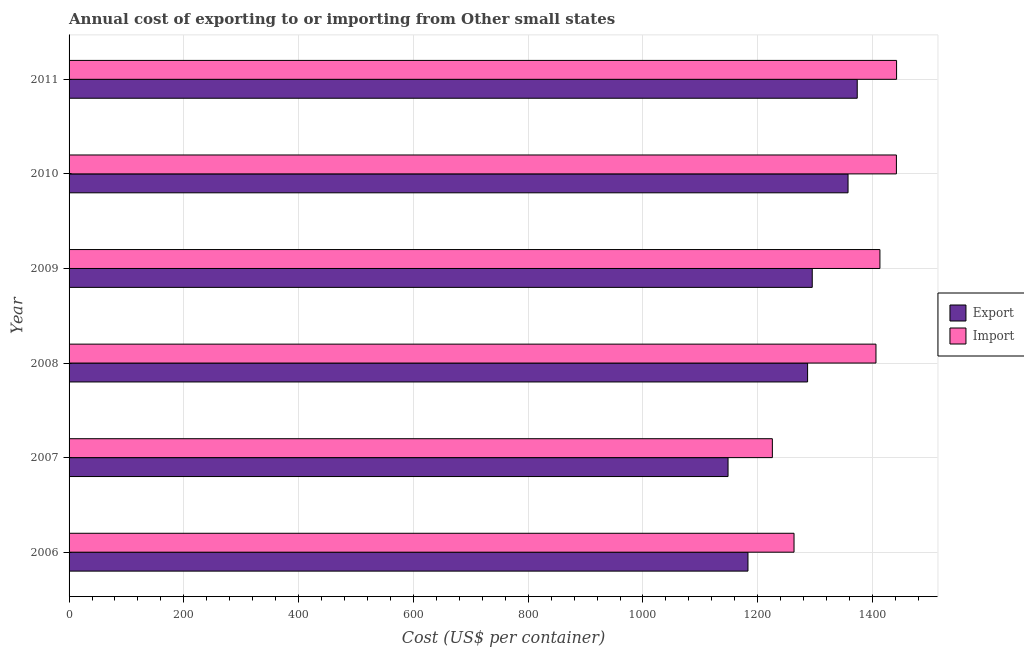How many different coloured bars are there?
Give a very brief answer. 2. Are the number of bars per tick equal to the number of legend labels?
Keep it short and to the point. Yes. How many bars are there on the 4th tick from the top?
Your answer should be very brief. 2. How many bars are there on the 1st tick from the bottom?
Provide a succinct answer. 2. What is the label of the 1st group of bars from the top?
Your answer should be very brief. 2011. In how many cases, is the number of bars for a given year not equal to the number of legend labels?
Provide a succinct answer. 0. What is the export cost in 2011?
Keep it short and to the point. 1373.39. Across all years, what is the maximum import cost?
Your response must be concise. 1441.94. Across all years, what is the minimum export cost?
Ensure brevity in your answer.  1148.28. In which year was the import cost maximum?
Ensure brevity in your answer.  2011. What is the total export cost in the graph?
Your answer should be very brief. 7643.94. What is the difference between the export cost in 2007 and that in 2008?
Keep it short and to the point. -138.61. What is the difference between the import cost in 2008 and the export cost in 2010?
Provide a short and direct response. 48.67. What is the average export cost per year?
Keep it short and to the point. 1273.99. In the year 2007, what is the difference between the import cost and export cost?
Provide a short and direct response. 77.22. In how many years, is the export cost greater than 1280 US$?
Offer a very short reply. 4. What is the ratio of the export cost in 2009 to that in 2011?
Your answer should be very brief. 0.94. Is the difference between the import cost in 2007 and 2010 greater than the difference between the export cost in 2007 and 2010?
Ensure brevity in your answer.  No. What is the difference between the highest and the lowest export cost?
Offer a very short reply. 225.11. What does the 2nd bar from the top in 2008 represents?
Keep it short and to the point. Export. What does the 1st bar from the bottom in 2010 represents?
Ensure brevity in your answer.  Export. Are all the bars in the graph horizontal?
Give a very brief answer. Yes. How many legend labels are there?
Ensure brevity in your answer.  2. What is the title of the graph?
Provide a succinct answer. Annual cost of exporting to or importing from Other small states. Does "Research and Development" appear as one of the legend labels in the graph?
Your response must be concise. No. What is the label or title of the X-axis?
Offer a terse response. Cost (US$ per container). What is the label or title of the Y-axis?
Provide a short and direct response. Year. What is the Cost (US$ per container) in Export in 2006?
Offer a very short reply. 1183. What is the Cost (US$ per container) in Import in 2006?
Ensure brevity in your answer.  1263.28. What is the Cost (US$ per container) of Export in 2007?
Keep it short and to the point. 1148.28. What is the Cost (US$ per container) in Import in 2007?
Offer a terse response. 1225.5. What is the Cost (US$ per container) in Export in 2008?
Your response must be concise. 1286.89. What is the Cost (US$ per container) of Import in 2008?
Keep it short and to the point. 1406.06. What is the Cost (US$ per container) in Export in 2009?
Ensure brevity in your answer.  1295. What is the Cost (US$ per container) in Import in 2009?
Provide a short and direct response. 1412.94. What is the Cost (US$ per container) in Export in 2010?
Your answer should be very brief. 1357.39. What is the Cost (US$ per container) of Import in 2010?
Your response must be concise. 1441.67. What is the Cost (US$ per container) of Export in 2011?
Make the answer very short. 1373.39. What is the Cost (US$ per container) in Import in 2011?
Ensure brevity in your answer.  1441.94. Across all years, what is the maximum Cost (US$ per container) of Export?
Give a very brief answer. 1373.39. Across all years, what is the maximum Cost (US$ per container) in Import?
Your response must be concise. 1441.94. Across all years, what is the minimum Cost (US$ per container) of Export?
Provide a succinct answer. 1148.28. Across all years, what is the minimum Cost (US$ per container) of Import?
Provide a succinct answer. 1225.5. What is the total Cost (US$ per container) in Export in the graph?
Give a very brief answer. 7643.94. What is the total Cost (US$ per container) of Import in the graph?
Ensure brevity in your answer.  8191.39. What is the difference between the Cost (US$ per container) of Export in 2006 and that in 2007?
Your answer should be very brief. 34.72. What is the difference between the Cost (US$ per container) of Import in 2006 and that in 2007?
Your answer should be compact. 37.78. What is the difference between the Cost (US$ per container) of Export in 2006 and that in 2008?
Give a very brief answer. -103.89. What is the difference between the Cost (US$ per container) in Import in 2006 and that in 2008?
Your response must be concise. -142.78. What is the difference between the Cost (US$ per container) of Export in 2006 and that in 2009?
Your response must be concise. -112. What is the difference between the Cost (US$ per container) of Import in 2006 and that in 2009?
Your answer should be compact. -149.67. What is the difference between the Cost (US$ per container) in Export in 2006 and that in 2010?
Give a very brief answer. -174.39. What is the difference between the Cost (US$ per container) of Import in 2006 and that in 2010?
Offer a very short reply. -178.39. What is the difference between the Cost (US$ per container) in Export in 2006 and that in 2011?
Provide a succinct answer. -190.39. What is the difference between the Cost (US$ per container) of Import in 2006 and that in 2011?
Make the answer very short. -178.67. What is the difference between the Cost (US$ per container) in Export in 2007 and that in 2008?
Your response must be concise. -138.61. What is the difference between the Cost (US$ per container) of Import in 2007 and that in 2008?
Give a very brief answer. -180.56. What is the difference between the Cost (US$ per container) of Export in 2007 and that in 2009?
Your response must be concise. -146.72. What is the difference between the Cost (US$ per container) in Import in 2007 and that in 2009?
Provide a short and direct response. -187.44. What is the difference between the Cost (US$ per container) in Export in 2007 and that in 2010?
Make the answer very short. -209.11. What is the difference between the Cost (US$ per container) in Import in 2007 and that in 2010?
Offer a terse response. -216.17. What is the difference between the Cost (US$ per container) of Export in 2007 and that in 2011?
Provide a succinct answer. -225.11. What is the difference between the Cost (US$ per container) of Import in 2007 and that in 2011?
Offer a very short reply. -216.44. What is the difference between the Cost (US$ per container) of Export in 2008 and that in 2009?
Your answer should be compact. -8.11. What is the difference between the Cost (US$ per container) of Import in 2008 and that in 2009?
Give a very brief answer. -6.89. What is the difference between the Cost (US$ per container) in Export in 2008 and that in 2010?
Provide a succinct answer. -70.5. What is the difference between the Cost (US$ per container) of Import in 2008 and that in 2010?
Give a very brief answer. -35.61. What is the difference between the Cost (US$ per container) of Export in 2008 and that in 2011?
Keep it short and to the point. -86.5. What is the difference between the Cost (US$ per container) of Import in 2008 and that in 2011?
Make the answer very short. -35.89. What is the difference between the Cost (US$ per container) of Export in 2009 and that in 2010?
Your answer should be very brief. -62.39. What is the difference between the Cost (US$ per container) in Import in 2009 and that in 2010?
Provide a succinct answer. -28.72. What is the difference between the Cost (US$ per container) in Export in 2009 and that in 2011?
Give a very brief answer. -78.39. What is the difference between the Cost (US$ per container) in Export in 2010 and that in 2011?
Offer a very short reply. -16. What is the difference between the Cost (US$ per container) of Import in 2010 and that in 2011?
Offer a terse response. -0.28. What is the difference between the Cost (US$ per container) in Export in 2006 and the Cost (US$ per container) in Import in 2007?
Your answer should be compact. -42.5. What is the difference between the Cost (US$ per container) in Export in 2006 and the Cost (US$ per container) in Import in 2008?
Your answer should be very brief. -223.06. What is the difference between the Cost (US$ per container) in Export in 2006 and the Cost (US$ per container) in Import in 2009?
Offer a terse response. -229.94. What is the difference between the Cost (US$ per container) of Export in 2006 and the Cost (US$ per container) of Import in 2010?
Ensure brevity in your answer.  -258.67. What is the difference between the Cost (US$ per container) of Export in 2006 and the Cost (US$ per container) of Import in 2011?
Give a very brief answer. -258.94. What is the difference between the Cost (US$ per container) of Export in 2007 and the Cost (US$ per container) of Import in 2008?
Offer a very short reply. -257.78. What is the difference between the Cost (US$ per container) in Export in 2007 and the Cost (US$ per container) in Import in 2009?
Your answer should be compact. -264.67. What is the difference between the Cost (US$ per container) of Export in 2007 and the Cost (US$ per container) of Import in 2010?
Provide a succinct answer. -293.39. What is the difference between the Cost (US$ per container) in Export in 2007 and the Cost (US$ per container) in Import in 2011?
Make the answer very short. -293.67. What is the difference between the Cost (US$ per container) of Export in 2008 and the Cost (US$ per container) of Import in 2009?
Your answer should be very brief. -126.06. What is the difference between the Cost (US$ per container) of Export in 2008 and the Cost (US$ per container) of Import in 2010?
Make the answer very short. -154.78. What is the difference between the Cost (US$ per container) in Export in 2008 and the Cost (US$ per container) in Import in 2011?
Offer a terse response. -155.06. What is the difference between the Cost (US$ per container) of Export in 2009 and the Cost (US$ per container) of Import in 2010?
Provide a succinct answer. -146.67. What is the difference between the Cost (US$ per container) of Export in 2009 and the Cost (US$ per container) of Import in 2011?
Your answer should be very brief. -146.94. What is the difference between the Cost (US$ per container) of Export in 2010 and the Cost (US$ per container) of Import in 2011?
Give a very brief answer. -84.56. What is the average Cost (US$ per container) in Export per year?
Keep it short and to the point. 1273.99. What is the average Cost (US$ per container) of Import per year?
Provide a short and direct response. 1365.23. In the year 2006, what is the difference between the Cost (US$ per container) of Export and Cost (US$ per container) of Import?
Your answer should be compact. -80.28. In the year 2007, what is the difference between the Cost (US$ per container) of Export and Cost (US$ per container) of Import?
Offer a terse response. -77.22. In the year 2008, what is the difference between the Cost (US$ per container) in Export and Cost (US$ per container) in Import?
Make the answer very short. -119.17. In the year 2009, what is the difference between the Cost (US$ per container) of Export and Cost (US$ per container) of Import?
Keep it short and to the point. -117.94. In the year 2010, what is the difference between the Cost (US$ per container) of Export and Cost (US$ per container) of Import?
Provide a succinct answer. -84.28. In the year 2011, what is the difference between the Cost (US$ per container) in Export and Cost (US$ per container) in Import?
Offer a terse response. -68.56. What is the ratio of the Cost (US$ per container) of Export in 2006 to that in 2007?
Offer a very short reply. 1.03. What is the ratio of the Cost (US$ per container) in Import in 2006 to that in 2007?
Your response must be concise. 1.03. What is the ratio of the Cost (US$ per container) in Export in 2006 to that in 2008?
Your response must be concise. 0.92. What is the ratio of the Cost (US$ per container) of Import in 2006 to that in 2008?
Your answer should be very brief. 0.9. What is the ratio of the Cost (US$ per container) in Export in 2006 to that in 2009?
Give a very brief answer. 0.91. What is the ratio of the Cost (US$ per container) of Import in 2006 to that in 2009?
Offer a very short reply. 0.89. What is the ratio of the Cost (US$ per container) of Export in 2006 to that in 2010?
Your response must be concise. 0.87. What is the ratio of the Cost (US$ per container) in Import in 2006 to that in 2010?
Provide a succinct answer. 0.88. What is the ratio of the Cost (US$ per container) in Export in 2006 to that in 2011?
Make the answer very short. 0.86. What is the ratio of the Cost (US$ per container) of Import in 2006 to that in 2011?
Make the answer very short. 0.88. What is the ratio of the Cost (US$ per container) of Export in 2007 to that in 2008?
Your answer should be compact. 0.89. What is the ratio of the Cost (US$ per container) of Import in 2007 to that in 2008?
Make the answer very short. 0.87. What is the ratio of the Cost (US$ per container) of Export in 2007 to that in 2009?
Give a very brief answer. 0.89. What is the ratio of the Cost (US$ per container) in Import in 2007 to that in 2009?
Keep it short and to the point. 0.87. What is the ratio of the Cost (US$ per container) in Export in 2007 to that in 2010?
Give a very brief answer. 0.85. What is the ratio of the Cost (US$ per container) in Import in 2007 to that in 2010?
Offer a very short reply. 0.85. What is the ratio of the Cost (US$ per container) in Export in 2007 to that in 2011?
Provide a succinct answer. 0.84. What is the ratio of the Cost (US$ per container) of Import in 2007 to that in 2011?
Keep it short and to the point. 0.85. What is the ratio of the Cost (US$ per container) in Import in 2008 to that in 2009?
Keep it short and to the point. 1. What is the ratio of the Cost (US$ per container) in Export in 2008 to that in 2010?
Ensure brevity in your answer.  0.95. What is the ratio of the Cost (US$ per container) in Import in 2008 to that in 2010?
Your answer should be compact. 0.98. What is the ratio of the Cost (US$ per container) in Export in 2008 to that in 2011?
Give a very brief answer. 0.94. What is the ratio of the Cost (US$ per container) in Import in 2008 to that in 2011?
Provide a succinct answer. 0.98. What is the ratio of the Cost (US$ per container) of Export in 2009 to that in 2010?
Your answer should be very brief. 0.95. What is the ratio of the Cost (US$ per container) of Import in 2009 to that in 2010?
Offer a very short reply. 0.98. What is the ratio of the Cost (US$ per container) in Export in 2009 to that in 2011?
Provide a succinct answer. 0.94. What is the ratio of the Cost (US$ per container) of Import in 2009 to that in 2011?
Make the answer very short. 0.98. What is the ratio of the Cost (US$ per container) of Export in 2010 to that in 2011?
Provide a short and direct response. 0.99. What is the difference between the highest and the second highest Cost (US$ per container) in Import?
Keep it short and to the point. 0.28. What is the difference between the highest and the lowest Cost (US$ per container) in Export?
Keep it short and to the point. 225.11. What is the difference between the highest and the lowest Cost (US$ per container) of Import?
Your response must be concise. 216.44. 